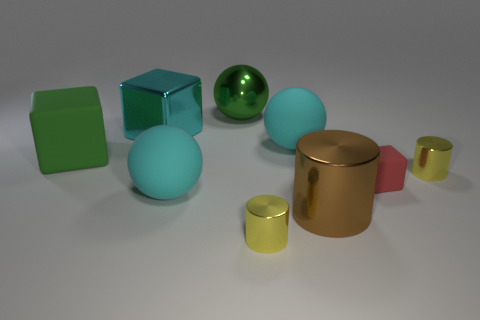Add 1 large cyan matte things. How many objects exist? 10 Subtract all spheres. How many objects are left? 6 Subtract all tiny green things. Subtract all green blocks. How many objects are left? 8 Add 7 big metallic balls. How many big metallic balls are left? 8 Add 2 big cyan blocks. How many big cyan blocks exist? 3 Subtract 1 brown cylinders. How many objects are left? 8 